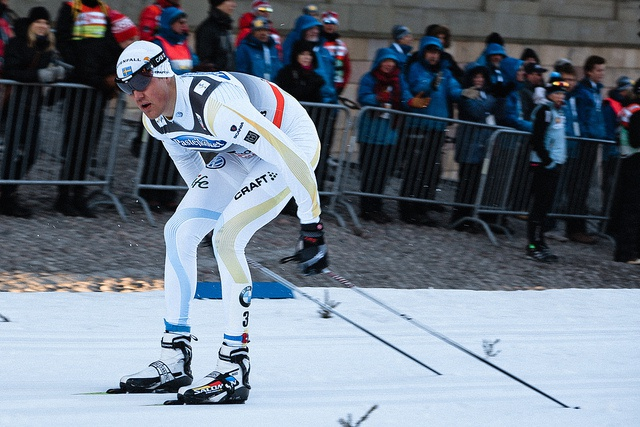Describe the objects in this image and their specific colors. I can see people in black, lavender, and lightblue tones, people in black, gray, navy, and blue tones, people in black, maroon, gray, and brown tones, people in black, navy, blue, and darkblue tones, and people in black, navy, gray, and blue tones in this image. 